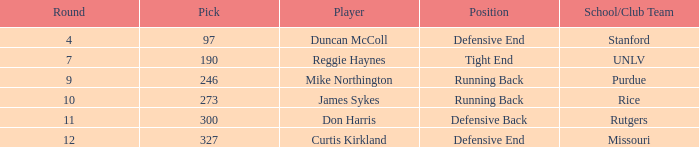What is the entire number of rounds containing draft pick 97, duncan mccoll? 0.0. 